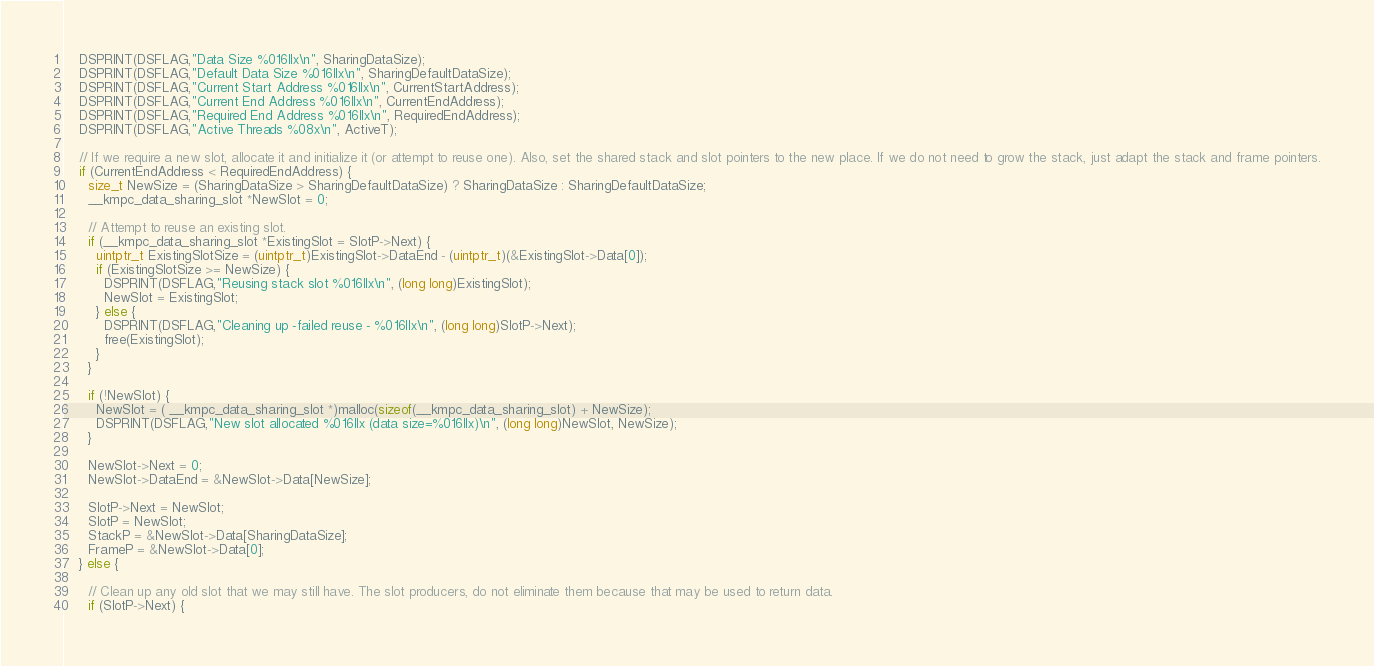Convert code to text. <code><loc_0><loc_0><loc_500><loc_500><_Cuda_>
    DSPRINT(DSFLAG,"Data Size %016llx\n", SharingDataSize);
    DSPRINT(DSFLAG,"Default Data Size %016llx\n", SharingDefaultDataSize);
    DSPRINT(DSFLAG,"Current Start Address %016llx\n", CurrentStartAddress);
    DSPRINT(DSFLAG,"Current End Address %016llx\n", CurrentEndAddress);
    DSPRINT(DSFLAG,"Required End Address %016llx\n", RequiredEndAddress);
    DSPRINT(DSFLAG,"Active Threads %08x\n", ActiveT);

    // If we require a new slot, allocate it and initialize it (or attempt to reuse one). Also, set the shared stack and slot pointers to the new place. If we do not need to grow the stack, just adapt the stack and frame pointers.
    if (CurrentEndAddress < RequiredEndAddress) {
      size_t NewSize = (SharingDataSize > SharingDefaultDataSize) ? SharingDataSize : SharingDefaultDataSize;
      __kmpc_data_sharing_slot *NewSlot = 0;

      // Attempt to reuse an existing slot.
      if (__kmpc_data_sharing_slot *ExistingSlot = SlotP->Next) {
        uintptr_t ExistingSlotSize = (uintptr_t)ExistingSlot->DataEnd - (uintptr_t)(&ExistingSlot->Data[0]);
        if (ExistingSlotSize >= NewSize) {
          DSPRINT(DSFLAG,"Reusing stack slot %016llx\n", (long long)ExistingSlot);
          NewSlot = ExistingSlot;
        } else {
          DSPRINT(DSFLAG,"Cleaning up -failed reuse - %016llx\n", (long long)SlotP->Next);
          free(ExistingSlot);
        }
      }

      if (!NewSlot) {
        NewSlot = ( __kmpc_data_sharing_slot *)malloc(sizeof(__kmpc_data_sharing_slot) + NewSize);
        DSPRINT(DSFLAG,"New slot allocated %016llx (data size=%016llx)\n", (long long)NewSlot, NewSize);
      }

      NewSlot->Next = 0;
      NewSlot->DataEnd = &NewSlot->Data[NewSize];

      SlotP->Next = NewSlot;
      SlotP = NewSlot;
      StackP = &NewSlot->Data[SharingDataSize];
      FrameP = &NewSlot->Data[0];
    } else {

      // Clean up any old slot that we may still have. The slot producers, do not eliminate them because that may be used to return data.
      if (SlotP->Next) {</code> 